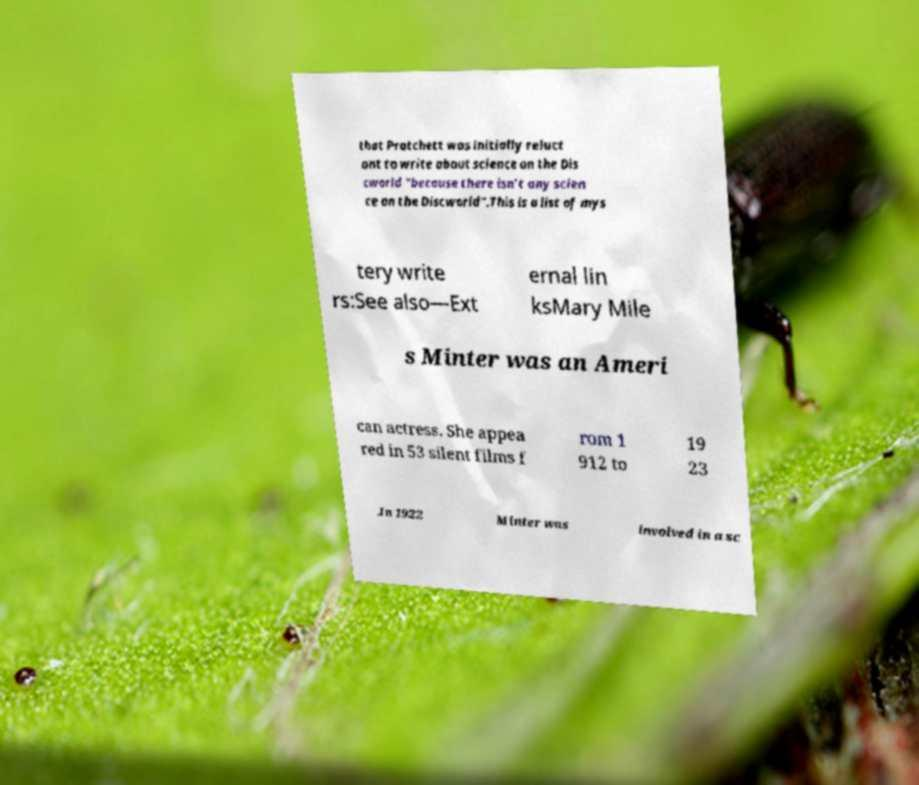Can you read and provide the text displayed in the image?This photo seems to have some interesting text. Can you extract and type it out for me? that Pratchett was initially reluct ant to write about science on the Dis cworld "because there isn’t any scien ce on the Discworld".This is a list of mys tery write rs:See also—Ext ernal lin ksMary Mile s Minter was an Ameri can actress. She appea red in 53 silent films f rom 1 912 to 19 23 .In 1922 Minter was involved in a sc 